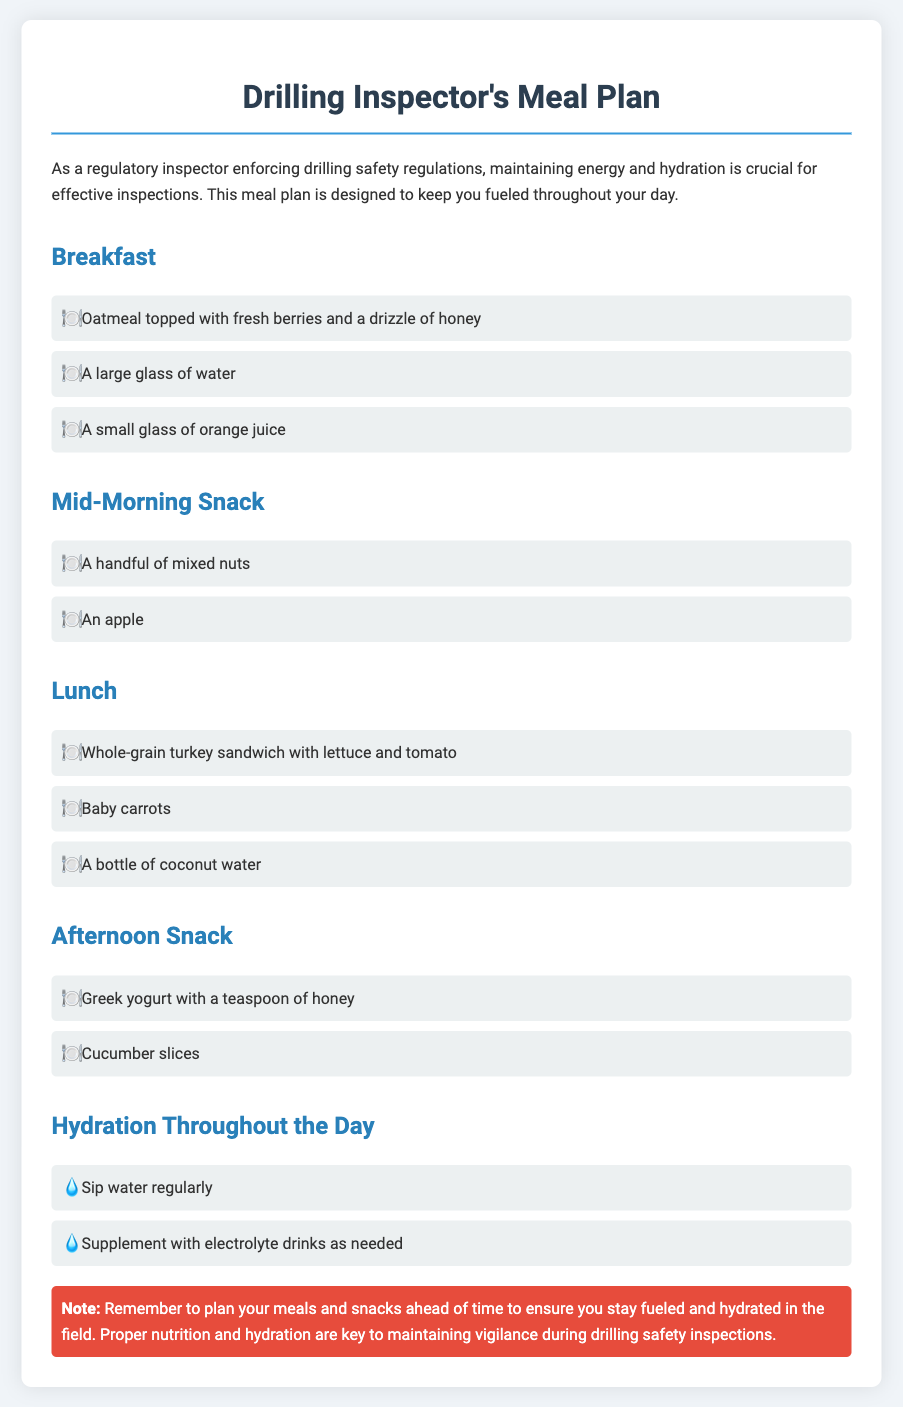What is included in breakfast? The breakfast section lists the items to be consumed, which are oatmeal, a large glass of water, and a small glass of orange juice.
Answer: Oatmeal topped with fresh berries and a drizzle of honey, a large glass of water, a small glass of orange juice What should be consumed during the mid-morning snack? The mid-morning snack section specifies two items: a handful of mixed nuts and an apple.
Answer: A handful of mixed nuts, an apple How many items are listed in the lunch section? The lunch section contains three items: a sandwich, baby carrots, and a drink.
Answer: Three What hydration method is suggested throughout the day? The document recommends specific hydration practices, namely sipping water and supplementing with electrolyte drinks as needed.
Answer: Sip water regularly, supplement with electrolyte drinks as needed What type of sandwich is mentioned for lunch? The lunch item specifies the type of sandwich to consume, which is made from whole-grain turkey with vegetables.
Answer: Whole-grain turkey sandwich with lettuce and tomato What is the purpose of the note at the bottom of the document? The note emphasizes the importance of meal planning for maintaining energy and hydration during fieldwork, especially for safety inspections.
Answer: Reminder to plan your meals and snacks ahead of time to ensure you stay fueled and hydrated in the field What is the main beverage recommended for hydration? The document indicates the main beverage for hydration mentioned is water, alongside coconut water as a specific drink choice during lunch.
Answer: Water, coconut water What is suggested as an afternoon snack? The afternoon snack section lists two items: Greek yogurt and cucumber slices, which are meant to provide energy.
Answer: Greek yogurt with a teaspoon of honey, cucumber slices 